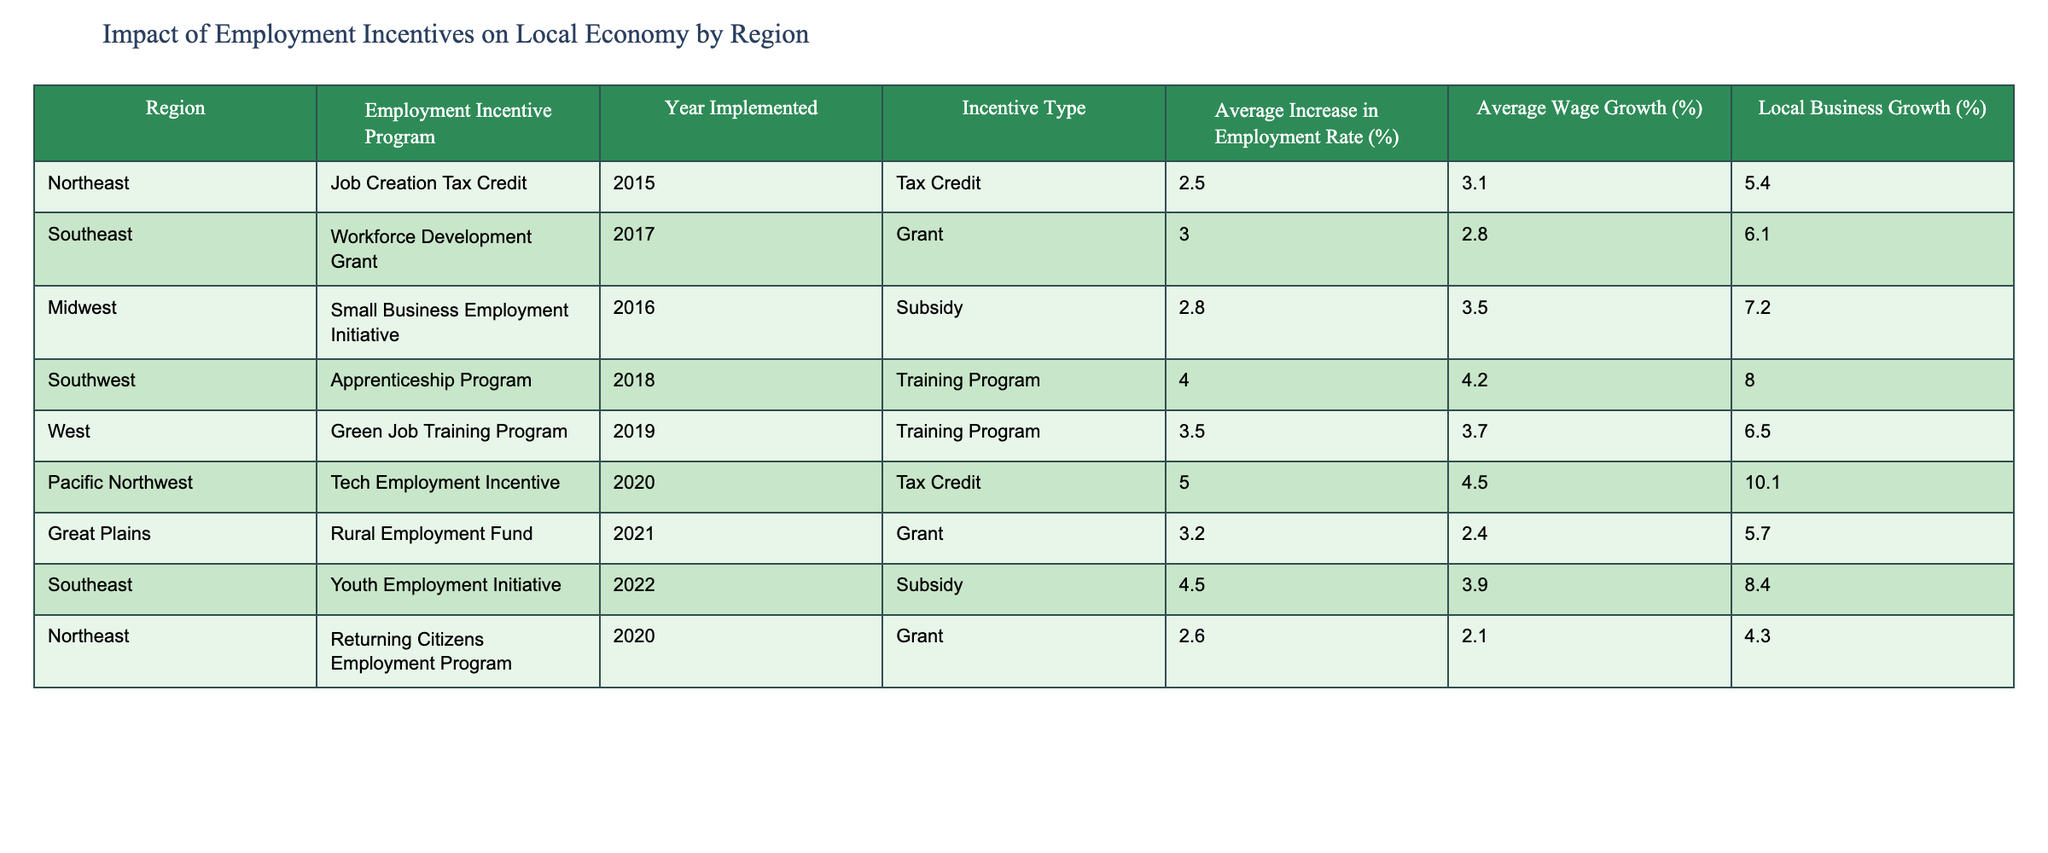What is the average increase in employment rate for the Southwest region? The table indicates that the average increase in employment rate for the Southwest region is 4.0%.
Answer: 4.0% Which region experienced the highest average wage growth and what was that percentage? By examining the table, the Pacific Northwest region has the highest average wage growth at 4.5%.
Answer: 4.5% Is the Employment Incentive Program that was implemented in 2015 offering a tax credit? According to the table, the program implemented in 2015 is the Job Creation Tax Credit, which is indeed a tax credit.
Answer: Yes What is the difference in average increase in employment rate between the Midwest and Southeast regions? The Midwest region has an average increase in employment rate of 2.8% and the Southeast has 3.0%. The difference is calculated as 3.0% - 2.8% = 0.2%.
Answer: 0.2% How many regions have an employment incentive program with an average wage growth percentage greater than 3.0%? The regions with an average wage growth greater than 3.0% are: Southwest (4.2%), Midwest (3.5%), Pacific Northwest (4.5%), and Southeast (3.9%). This totals to 4 regions.
Answer: 4 Which incentive type has the highest average increase in local business growth, and what is that percentage? The Southwest's Apprenticeship Program, which is a training program, has the highest average increase in local business growth at 8.0%.
Answer: 8.0% Are there more regions with grant type employment incentives than with subsidy type incentives? The table shows that there are 3 grant programs (Workforce Development Grant, Rural Employment Fund, Returning Citizens Employment Program) and 3 subsidy programs (Small Business Employment Initiative, Youth Employment Initiative, Returning Citizens Employment Program). Therefore, they are equal.
Answer: No What is the average local business growth for all regions combined? To find the average, we sum the local business growth percentages (5.4 + 6.1 + 7.2 + 8.0 + 6.5 + 10.1 + 5.7 + 8.4) = 57.4%. Dividing by the number of regions (8), we get an average local business growth of 57.4% / 8 = 7.175%.
Answer: 7.175% How does the average increase in employment rate for tax credit programs compare to that of training programs? For tax credit programs, the average increase in employment rate is (2.5% + 5.0%) / 2 = 3.75%. For training programs, it’s (4.0% + 3.5%) / 2 = 3.75%. Thus, they are equal.
Answer: Equal 